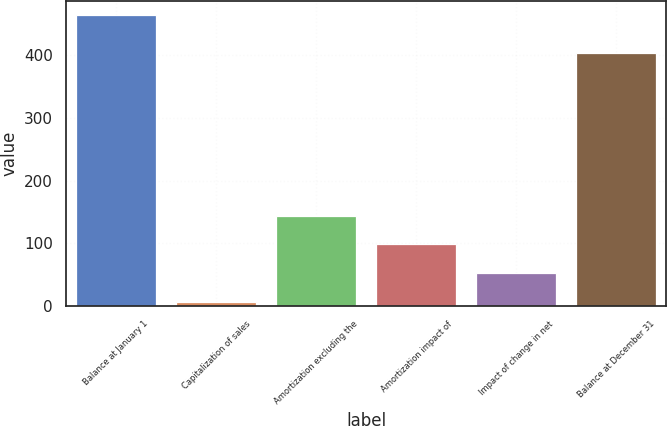Convert chart to OTSL. <chart><loc_0><loc_0><loc_500><loc_500><bar_chart><fcel>Balance at January 1<fcel>Capitalization of sales<fcel>Amortization excluding the<fcel>Amortization impact of<fcel>Impact of change in net<fcel>Balance at December 31<nl><fcel>464<fcel>7<fcel>144.1<fcel>98.4<fcel>52.7<fcel>404<nl></chart> 